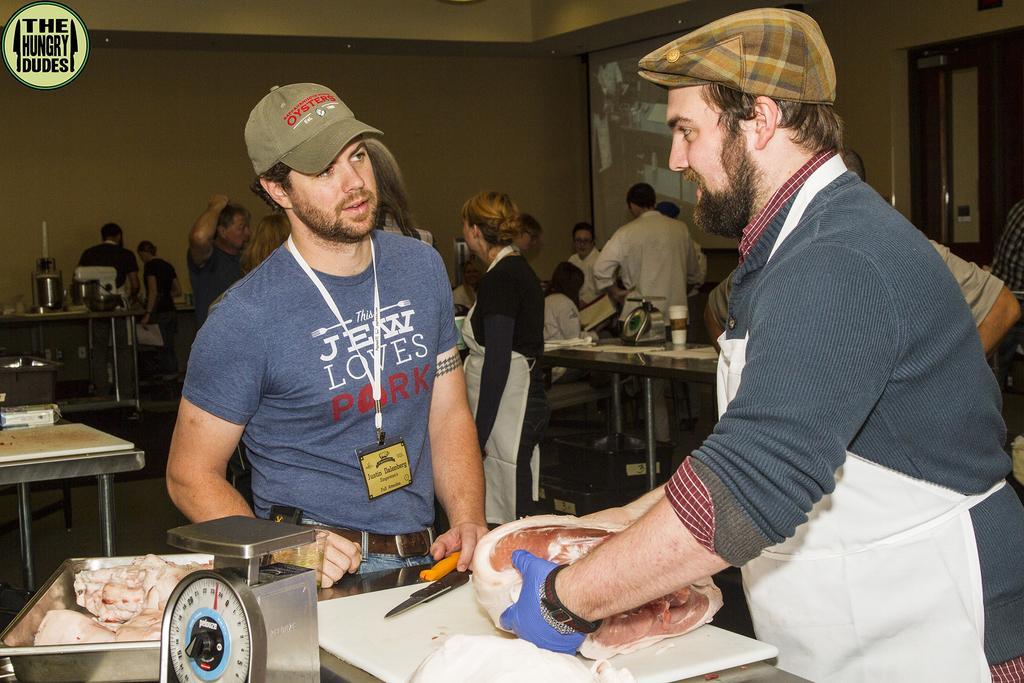Could you give a brief overview of what you see in this image? In this image I can see a person wearing wearing blue and white colored dress is standing and holding a piece of meat. I can see another person standing, a tray with some meat in it and a weighing machine. In the background I can see few other persons standing, few tables, the wall, a screen and the door. 